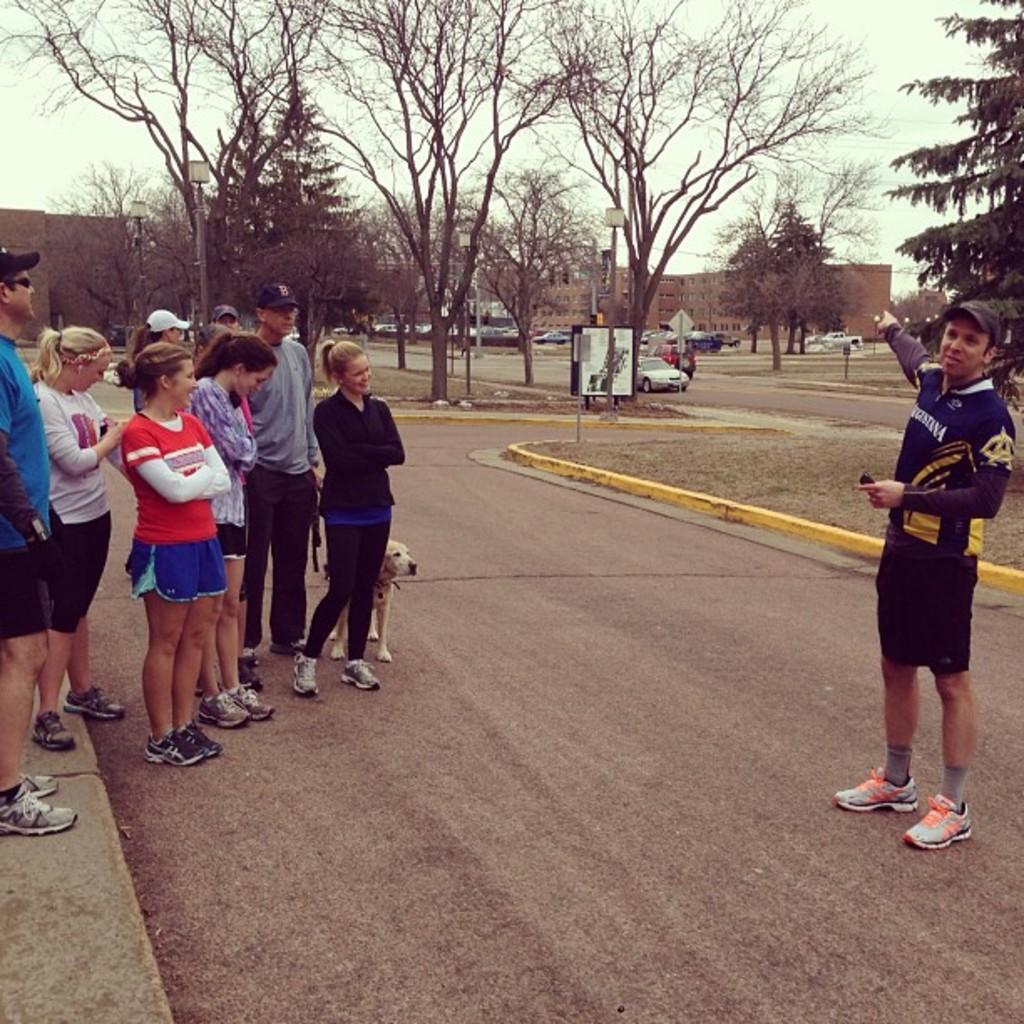Who or what can be seen in the image? There are people in the image. Where are the people located? The people are standing on the road. What can be seen in the background of the image? There are trees and buildings visible in the image. Is there a tiger hiding behind the trees in the image? No, there is no tiger present in the image. 